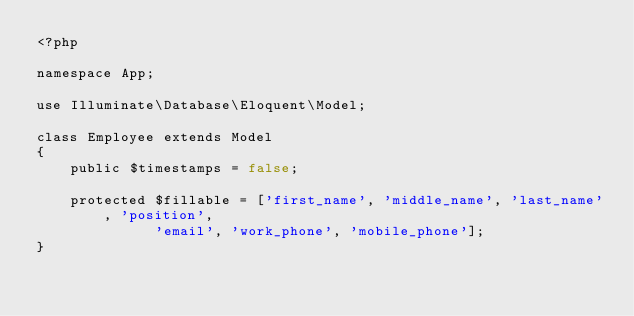<code> <loc_0><loc_0><loc_500><loc_500><_PHP_><?php

namespace App;

use Illuminate\Database\Eloquent\Model;

class Employee extends Model
{
    public $timestamps = false;

    protected $fillable = ['first_name', 'middle_name', 'last_name', 'position',
							'email', 'work_phone', 'mobile_phone'];
}
</code> 